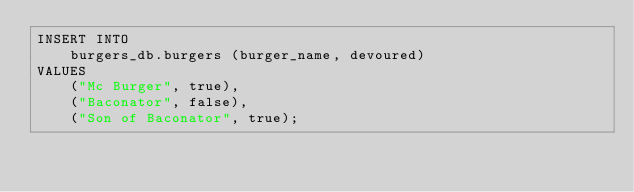Convert code to text. <code><loc_0><loc_0><loc_500><loc_500><_SQL_>INSERT INTO 
    burgers_db.burgers (burger_name, devoured) 
VALUES 
    ("Mc Burger", true),
    ("Baconator", false),
    ("Son of Baconator", true);</code> 